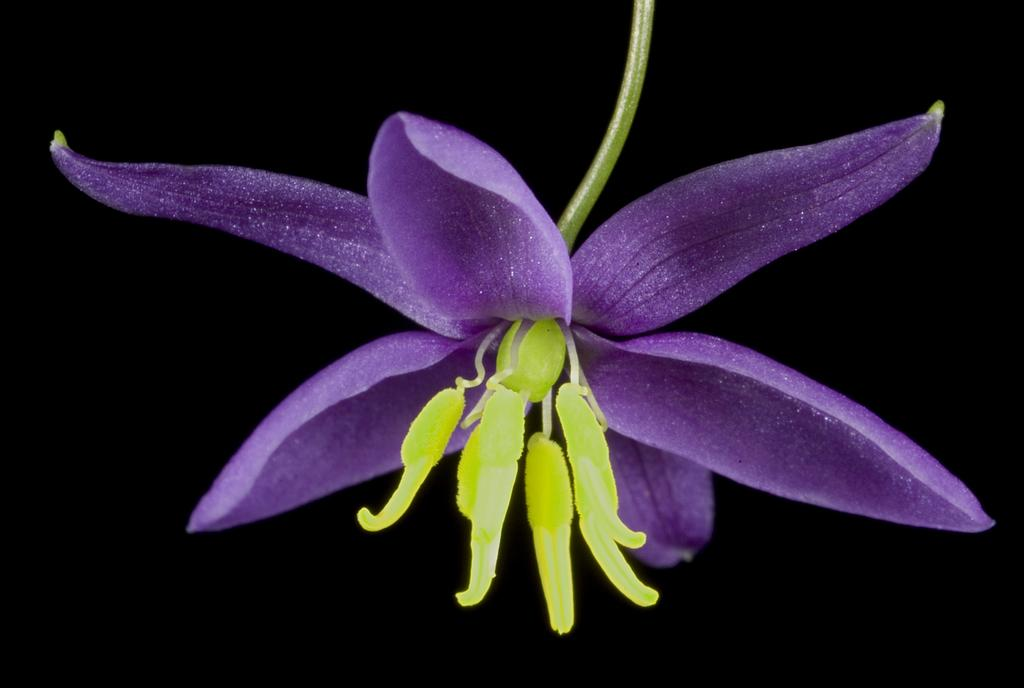What is the main subject in the foreground of the image? There is a purple color flower in the foreground of the image. What color is the flower? The flower is purple. What can be seen in the background of the image? The background of the image is black. How many babies are visible in the image? There are no babies present in the image; it features a purple flower in the foreground and a black background. What invention is being demonstrated in the image? There is no invention being demonstrated in the image; it simply shows a purple flower in the foreground and a black background. 